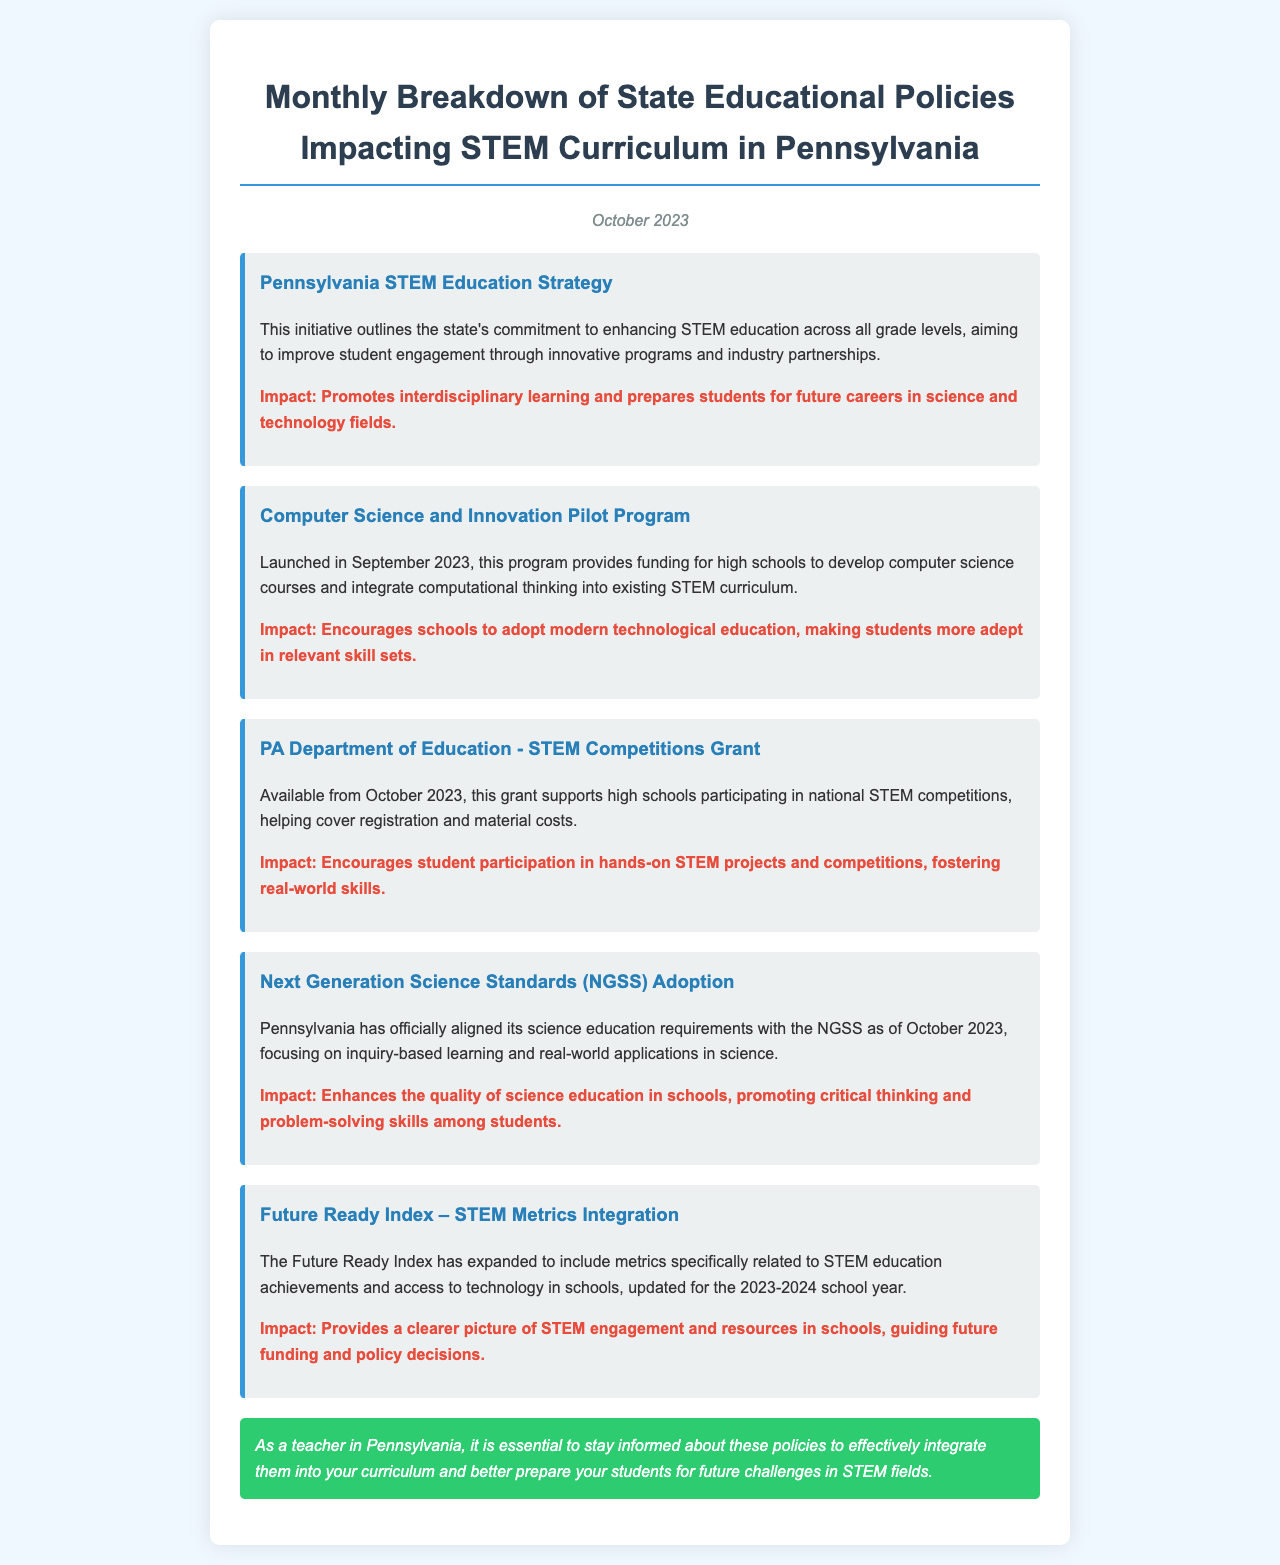What is the title of the newsletter? The title indicates the content of the newsletter, which focuses on educational policies.
Answer: Monthly Breakdown of State Educational Policies Impacting STEM Curriculum in Pennsylvania When was the Computer Science and Innovation Pilot Program launched? This refers to the date when the specific initiative was put into effect, which can be found in the document.
Answer: September 2023 What is the primary focus of Pennsylvania's STEM Education Strategy? This question seeks to uncover the main goal of the state's educational initiative.
Answer: Enhancing STEM education across all grade levels What new educational standards has Pennsylvania adopted as of October 2023? This is looking for specific guidelines that the state has aligned with, related to science education.
Answer: Next Generation Science Standards (NGSS) What does the STEM Competitions Grant support? This query aims to identify the purpose of the grant mentioned in the document.
Answer: High schools participating in national STEM competitions How many areas of impact are listed for the Pennsylvania STEM Education Strategy? This asks for a count of the distinct impacts mentioned for the specific initiative.
Answer: One What does the Future Ready Index now include for the 2023-2024 school year? This question relates to the updated content of the Future Ready Index as described in the document.
Answer: STEM metrics What is the color of the closing note background? This inquires about a specific design element of the newsletter document.
Answer: Green 